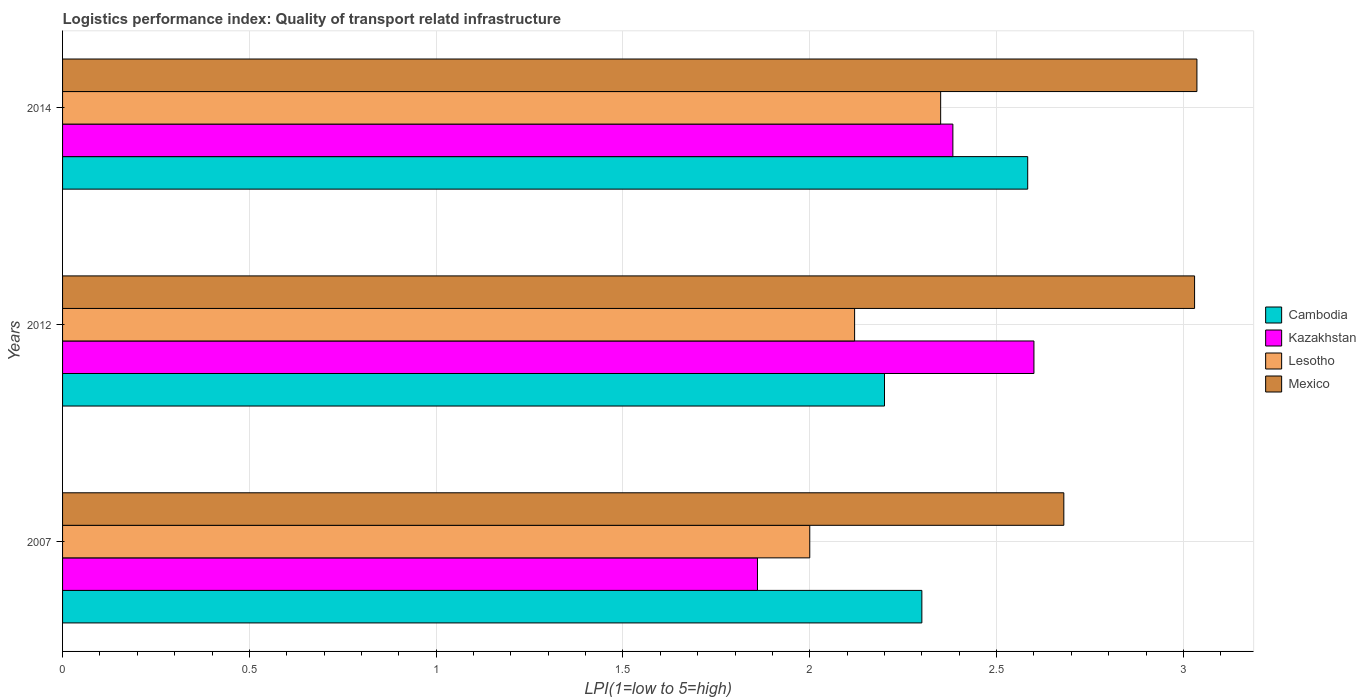How many different coloured bars are there?
Your response must be concise. 4. Are the number of bars per tick equal to the number of legend labels?
Your answer should be very brief. Yes. Are the number of bars on each tick of the Y-axis equal?
Ensure brevity in your answer.  Yes. How many bars are there on the 3rd tick from the bottom?
Keep it short and to the point. 4. What is the label of the 3rd group of bars from the top?
Offer a terse response. 2007. Across all years, what is the maximum logistics performance index in Mexico?
Ensure brevity in your answer.  3.04. Across all years, what is the minimum logistics performance index in Mexico?
Your answer should be very brief. 2.68. What is the total logistics performance index in Mexico in the graph?
Your answer should be compact. 8.75. What is the difference between the logistics performance index in Mexico in 2012 and that in 2014?
Offer a very short reply. -0.01. What is the difference between the logistics performance index in Kazakhstan in 2007 and the logistics performance index in Mexico in 2012?
Ensure brevity in your answer.  -1.17. What is the average logistics performance index in Lesotho per year?
Keep it short and to the point. 2.16. In the year 2007, what is the difference between the logistics performance index in Kazakhstan and logistics performance index in Cambodia?
Ensure brevity in your answer.  -0.44. What is the ratio of the logistics performance index in Kazakhstan in 2007 to that in 2014?
Offer a terse response. 0.78. Is the difference between the logistics performance index in Kazakhstan in 2012 and 2014 greater than the difference between the logistics performance index in Cambodia in 2012 and 2014?
Provide a short and direct response. Yes. What is the difference between the highest and the second highest logistics performance index in Mexico?
Provide a short and direct response. 0.01. What is the difference between the highest and the lowest logistics performance index in Kazakhstan?
Provide a short and direct response. 0.74. In how many years, is the logistics performance index in Mexico greater than the average logistics performance index in Mexico taken over all years?
Ensure brevity in your answer.  2. What does the 4th bar from the top in 2012 represents?
Make the answer very short. Cambodia. What does the 3rd bar from the bottom in 2012 represents?
Provide a short and direct response. Lesotho. How many bars are there?
Give a very brief answer. 12. How many years are there in the graph?
Offer a terse response. 3. What is the difference between two consecutive major ticks on the X-axis?
Offer a terse response. 0.5. Does the graph contain any zero values?
Keep it short and to the point. No. How many legend labels are there?
Your answer should be very brief. 4. How are the legend labels stacked?
Your answer should be compact. Vertical. What is the title of the graph?
Provide a short and direct response. Logistics performance index: Quality of transport relatd infrastructure. Does "Ukraine" appear as one of the legend labels in the graph?
Your answer should be very brief. No. What is the label or title of the X-axis?
Offer a terse response. LPI(1=low to 5=high). What is the label or title of the Y-axis?
Your response must be concise. Years. What is the LPI(1=low to 5=high) in Cambodia in 2007?
Provide a short and direct response. 2.3. What is the LPI(1=low to 5=high) in Kazakhstan in 2007?
Your response must be concise. 1.86. What is the LPI(1=low to 5=high) of Lesotho in 2007?
Give a very brief answer. 2. What is the LPI(1=low to 5=high) in Mexico in 2007?
Give a very brief answer. 2.68. What is the LPI(1=low to 5=high) of Lesotho in 2012?
Ensure brevity in your answer.  2.12. What is the LPI(1=low to 5=high) of Mexico in 2012?
Your answer should be compact. 3.03. What is the LPI(1=low to 5=high) of Cambodia in 2014?
Provide a short and direct response. 2.58. What is the LPI(1=low to 5=high) of Kazakhstan in 2014?
Your response must be concise. 2.38. What is the LPI(1=low to 5=high) in Lesotho in 2014?
Ensure brevity in your answer.  2.35. What is the LPI(1=low to 5=high) of Mexico in 2014?
Offer a very short reply. 3.04. Across all years, what is the maximum LPI(1=low to 5=high) of Cambodia?
Keep it short and to the point. 2.58. Across all years, what is the maximum LPI(1=low to 5=high) in Lesotho?
Offer a very short reply. 2.35. Across all years, what is the maximum LPI(1=low to 5=high) in Mexico?
Keep it short and to the point. 3.04. Across all years, what is the minimum LPI(1=low to 5=high) of Kazakhstan?
Make the answer very short. 1.86. Across all years, what is the minimum LPI(1=low to 5=high) in Mexico?
Make the answer very short. 2.68. What is the total LPI(1=low to 5=high) of Cambodia in the graph?
Make the answer very short. 7.08. What is the total LPI(1=low to 5=high) of Kazakhstan in the graph?
Your answer should be compact. 6.84. What is the total LPI(1=low to 5=high) in Lesotho in the graph?
Provide a short and direct response. 6.47. What is the total LPI(1=low to 5=high) in Mexico in the graph?
Provide a short and direct response. 8.75. What is the difference between the LPI(1=low to 5=high) in Cambodia in 2007 and that in 2012?
Your answer should be compact. 0.1. What is the difference between the LPI(1=low to 5=high) of Kazakhstan in 2007 and that in 2012?
Ensure brevity in your answer.  -0.74. What is the difference between the LPI(1=low to 5=high) of Lesotho in 2007 and that in 2012?
Your response must be concise. -0.12. What is the difference between the LPI(1=low to 5=high) of Mexico in 2007 and that in 2012?
Ensure brevity in your answer.  -0.35. What is the difference between the LPI(1=low to 5=high) of Cambodia in 2007 and that in 2014?
Offer a terse response. -0.28. What is the difference between the LPI(1=low to 5=high) in Kazakhstan in 2007 and that in 2014?
Keep it short and to the point. -0.52. What is the difference between the LPI(1=low to 5=high) of Lesotho in 2007 and that in 2014?
Offer a terse response. -0.35. What is the difference between the LPI(1=low to 5=high) in Mexico in 2007 and that in 2014?
Offer a very short reply. -0.36. What is the difference between the LPI(1=low to 5=high) in Cambodia in 2012 and that in 2014?
Your response must be concise. -0.38. What is the difference between the LPI(1=low to 5=high) of Kazakhstan in 2012 and that in 2014?
Give a very brief answer. 0.22. What is the difference between the LPI(1=low to 5=high) of Lesotho in 2012 and that in 2014?
Your answer should be compact. -0.23. What is the difference between the LPI(1=low to 5=high) of Mexico in 2012 and that in 2014?
Ensure brevity in your answer.  -0.01. What is the difference between the LPI(1=low to 5=high) of Cambodia in 2007 and the LPI(1=low to 5=high) of Kazakhstan in 2012?
Make the answer very short. -0.3. What is the difference between the LPI(1=low to 5=high) in Cambodia in 2007 and the LPI(1=low to 5=high) in Lesotho in 2012?
Give a very brief answer. 0.18. What is the difference between the LPI(1=low to 5=high) of Cambodia in 2007 and the LPI(1=low to 5=high) of Mexico in 2012?
Give a very brief answer. -0.73. What is the difference between the LPI(1=low to 5=high) in Kazakhstan in 2007 and the LPI(1=low to 5=high) in Lesotho in 2012?
Your response must be concise. -0.26. What is the difference between the LPI(1=low to 5=high) of Kazakhstan in 2007 and the LPI(1=low to 5=high) of Mexico in 2012?
Provide a short and direct response. -1.17. What is the difference between the LPI(1=low to 5=high) of Lesotho in 2007 and the LPI(1=low to 5=high) of Mexico in 2012?
Make the answer very short. -1.03. What is the difference between the LPI(1=low to 5=high) in Cambodia in 2007 and the LPI(1=low to 5=high) in Kazakhstan in 2014?
Give a very brief answer. -0.08. What is the difference between the LPI(1=low to 5=high) in Cambodia in 2007 and the LPI(1=low to 5=high) in Lesotho in 2014?
Offer a terse response. -0.05. What is the difference between the LPI(1=low to 5=high) in Cambodia in 2007 and the LPI(1=low to 5=high) in Mexico in 2014?
Your response must be concise. -0.74. What is the difference between the LPI(1=low to 5=high) of Kazakhstan in 2007 and the LPI(1=low to 5=high) of Lesotho in 2014?
Your response must be concise. -0.49. What is the difference between the LPI(1=low to 5=high) in Kazakhstan in 2007 and the LPI(1=low to 5=high) in Mexico in 2014?
Provide a short and direct response. -1.18. What is the difference between the LPI(1=low to 5=high) in Lesotho in 2007 and the LPI(1=low to 5=high) in Mexico in 2014?
Provide a short and direct response. -1.04. What is the difference between the LPI(1=low to 5=high) in Cambodia in 2012 and the LPI(1=low to 5=high) in Kazakhstan in 2014?
Offer a very short reply. -0.18. What is the difference between the LPI(1=low to 5=high) in Cambodia in 2012 and the LPI(1=low to 5=high) in Lesotho in 2014?
Offer a terse response. -0.15. What is the difference between the LPI(1=low to 5=high) of Cambodia in 2012 and the LPI(1=low to 5=high) of Mexico in 2014?
Provide a short and direct response. -0.84. What is the difference between the LPI(1=low to 5=high) in Kazakhstan in 2012 and the LPI(1=low to 5=high) in Lesotho in 2014?
Provide a short and direct response. 0.25. What is the difference between the LPI(1=low to 5=high) in Kazakhstan in 2012 and the LPI(1=low to 5=high) in Mexico in 2014?
Give a very brief answer. -0.44. What is the difference between the LPI(1=low to 5=high) in Lesotho in 2012 and the LPI(1=low to 5=high) in Mexico in 2014?
Provide a succinct answer. -0.92. What is the average LPI(1=low to 5=high) of Cambodia per year?
Keep it short and to the point. 2.36. What is the average LPI(1=low to 5=high) in Kazakhstan per year?
Provide a short and direct response. 2.28. What is the average LPI(1=low to 5=high) of Lesotho per year?
Offer a very short reply. 2.16. What is the average LPI(1=low to 5=high) in Mexico per year?
Provide a short and direct response. 2.92. In the year 2007, what is the difference between the LPI(1=low to 5=high) of Cambodia and LPI(1=low to 5=high) of Kazakhstan?
Provide a succinct answer. 0.44. In the year 2007, what is the difference between the LPI(1=low to 5=high) of Cambodia and LPI(1=low to 5=high) of Mexico?
Give a very brief answer. -0.38. In the year 2007, what is the difference between the LPI(1=low to 5=high) of Kazakhstan and LPI(1=low to 5=high) of Lesotho?
Ensure brevity in your answer.  -0.14. In the year 2007, what is the difference between the LPI(1=low to 5=high) in Kazakhstan and LPI(1=low to 5=high) in Mexico?
Your answer should be very brief. -0.82. In the year 2007, what is the difference between the LPI(1=low to 5=high) in Lesotho and LPI(1=low to 5=high) in Mexico?
Provide a succinct answer. -0.68. In the year 2012, what is the difference between the LPI(1=low to 5=high) of Cambodia and LPI(1=low to 5=high) of Kazakhstan?
Your response must be concise. -0.4. In the year 2012, what is the difference between the LPI(1=low to 5=high) of Cambodia and LPI(1=low to 5=high) of Mexico?
Offer a terse response. -0.83. In the year 2012, what is the difference between the LPI(1=low to 5=high) of Kazakhstan and LPI(1=low to 5=high) of Lesotho?
Provide a short and direct response. 0.48. In the year 2012, what is the difference between the LPI(1=low to 5=high) in Kazakhstan and LPI(1=low to 5=high) in Mexico?
Give a very brief answer. -0.43. In the year 2012, what is the difference between the LPI(1=low to 5=high) of Lesotho and LPI(1=low to 5=high) of Mexico?
Your response must be concise. -0.91. In the year 2014, what is the difference between the LPI(1=low to 5=high) in Cambodia and LPI(1=low to 5=high) in Kazakhstan?
Keep it short and to the point. 0.2. In the year 2014, what is the difference between the LPI(1=low to 5=high) in Cambodia and LPI(1=low to 5=high) in Lesotho?
Keep it short and to the point. 0.23. In the year 2014, what is the difference between the LPI(1=low to 5=high) in Cambodia and LPI(1=low to 5=high) in Mexico?
Your answer should be compact. -0.45. In the year 2014, what is the difference between the LPI(1=low to 5=high) in Kazakhstan and LPI(1=low to 5=high) in Lesotho?
Make the answer very short. 0.03. In the year 2014, what is the difference between the LPI(1=low to 5=high) of Kazakhstan and LPI(1=low to 5=high) of Mexico?
Provide a succinct answer. -0.65. In the year 2014, what is the difference between the LPI(1=low to 5=high) of Lesotho and LPI(1=low to 5=high) of Mexico?
Make the answer very short. -0.69. What is the ratio of the LPI(1=low to 5=high) of Cambodia in 2007 to that in 2012?
Offer a terse response. 1.05. What is the ratio of the LPI(1=low to 5=high) of Kazakhstan in 2007 to that in 2012?
Your response must be concise. 0.72. What is the ratio of the LPI(1=low to 5=high) of Lesotho in 2007 to that in 2012?
Ensure brevity in your answer.  0.94. What is the ratio of the LPI(1=low to 5=high) of Mexico in 2007 to that in 2012?
Give a very brief answer. 0.88. What is the ratio of the LPI(1=low to 5=high) in Cambodia in 2007 to that in 2014?
Make the answer very short. 0.89. What is the ratio of the LPI(1=low to 5=high) in Kazakhstan in 2007 to that in 2014?
Your answer should be very brief. 0.78. What is the ratio of the LPI(1=low to 5=high) in Lesotho in 2007 to that in 2014?
Offer a very short reply. 0.85. What is the ratio of the LPI(1=low to 5=high) of Mexico in 2007 to that in 2014?
Give a very brief answer. 0.88. What is the ratio of the LPI(1=low to 5=high) in Cambodia in 2012 to that in 2014?
Provide a short and direct response. 0.85. What is the ratio of the LPI(1=low to 5=high) in Kazakhstan in 2012 to that in 2014?
Make the answer very short. 1.09. What is the ratio of the LPI(1=low to 5=high) of Lesotho in 2012 to that in 2014?
Your answer should be very brief. 0.9. What is the difference between the highest and the second highest LPI(1=low to 5=high) of Cambodia?
Keep it short and to the point. 0.28. What is the difference between the highest and the second highest LPI(1=low to 5=high) of Kazakhstan?
Ensure brevity in your answer.  0.22. What is the difference between the highest and the second highest LPI(1=low to 5=high) in Lesotho?
Ensure brevity in your answer.  0.23. What is the difference between the highest and the second highest LPI(1=low to 5=high) of Mexico?
Your answer should be compact. 0.01. What is the difference between the highest and the lowest LPI(1=low to 5=high) in Cambodia?
Your answer should be very brief. 0.38. What is the difference between the highest and the lowest LPI(1=low to 5=high) in Kazakhstan?
Provide a short and direct response. 0.74. What is the difference between the highest and the lowest LPI(1=low to 5=high) in Lesotho?
Offer a very short reply. 0.35. What is the difference between the highest and the lowest LPI(1=low to 5=high) in Mexico?
Your answer should be compact. 0.36. 